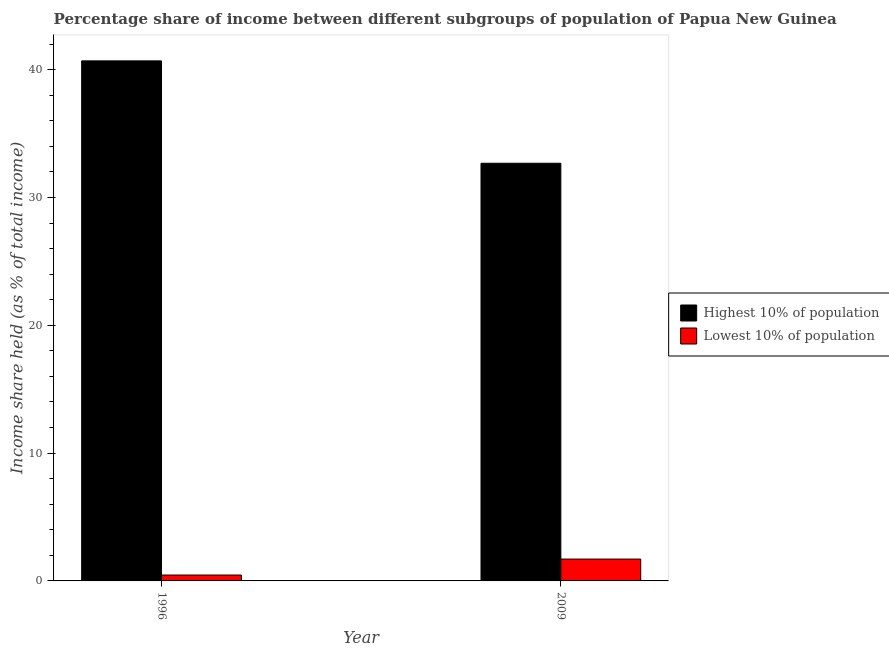How many groups of bars are there?
Your answer should be compact. 2. Are the number of bars per tick equal to the number of legend labels?
Offer a terse response. Yes. How many bars are there on the 1st tick from the left?
Your answer should be compact. 2. What is the income share held by highest 10% of the population in 1996?
Provide a succinct answer. 40.69. Across all years, what is the maximum income share held by lowest 10% of the population?
Provide a succinct answer. 1.71. Across all years, what is the minimum income share held by highest 10% of the population?
Ensure brevity in your answer.  32.68. What is the total income share held by highest 10% of the population in the graph?
Keep it short and to the point. 73.37. What is the difference between the income share held by highest 10% of the population in 1996 and that in 2009?
Keep it short and to the point. 8.01. What is the difference between the income share held by highest 10% of the population in 2009 and the income share held by lowest 10% of the population in 1996?
Your answer should be compact. -8.01. What is the average income share held by lowest 10% of the population per year?
Ensure brevity in your answer.  1.08. In the year 2009, what is the difference between the income share held by lowest 10% of the population and income share held by highest 10% of the population?
Your response must be concise. 0. In how many years, is the income share held by lowest 10% of the population greater than 28 %?
Your response must be concise. 0. What is the ratio of the income share held by highest 10% of the population in 1996 to that in 2009?
Provide a succinct answer. 1.25. Is the income share held by lowest 10% of the population in 1996 less than that in 2009?
Provide a short and direct response. Yes. In how many years, is the income share held by highest 10% of the population greater than the average income share held by highest 10% of the population taken over all years?
Your answer should be compact. 1. What does the 1st bar from the left in 2009 represents?
Provide a succinct answer. Highest 10% of population. What does the 1st bar from the right in 1996 represents?
Give a very brief answer. Lowest 10% of population. How many bars are there?
Your answer should be compact. 4. Are all the bars in the graph horizontal?
Provide a succinct answer. No. How many years are there in the graph?
Offer a terse response. 2. Does the graph contain any zero values?
Give a very brief answer. No. Where does the legend appear in the graph?
Provide a succinct answer. Center right. What is the title of the graph?
Your answer should be compact. Percentage share of income between different subgroups of population of Papua New Guinea. What is the label or title of the Y-axis?
Ensure brevity in your answer.  Income share held (as % of total income). What is the Income share held (as % of total income) in Highest 10% of population in 1996?
Your answer should be compact. 40.69. What is the Income share held (as % of total income) of Lowest 10% of population in 1996?
Provide a succinct answer. 0.46. What is the Income share held (as % of total income) in Highest 10% of population in 2009?
Offer a terse response. 32.68. What is the Income share held (as % of total income) of Lowest 10% of population in 2009?
Provide a succinct answer. 1.71. Across all years, what is the maximum Income share held (as % of total income) of Highest 10% of population?
Make the answer very short. 40.69. Across all years, what is the maximum Income share held (as % of total income) in Lowest 10% of population?
Your answer should be compact. 1.71. Across all years, what is the minimum Income share held (as % of total income) of Highest 10% of population?
Keep it short and to the point. 32.68. Across all years, what is the minimum Income share held (as % of total income) in Lowest 10% of population?
Offer a terse response. 0.46. What is the total Income share held (as % of total income) of Highest 10% of population in the graph?
Keep it short and to the point. 73.37. What is the total Income share held (as % of total income) in Lowest 10% of population in the graph?
Ensure brevity in your answer.  2.17. What is the difference between the Income share held (as % of total income) in Highest 10% of population in 1996 and that in 2009?
Your response must be concise. 8.01. What is the difference between the Income share held (as % of total income) in Lowest 10% of population in 1996 and that in 2009?
Make the answer very short. -1.25. What is the difference between the Income share held (as % of total income) of Highest 10% of population in 1996 and the Income share held (as % of total income) of Lowest 10% of population in 2009?
Your answer should be very brief. 38.98. What is the average Income share held (as % of total income) of Highest 10% of population per year?
Your response must be concise. 36.69. What is the average Income share held (as % of total income) in Lowest 10% of population per year?
Keep it short and to the point. 1.08. In the year 1996, what is the difference between the Income share held (as % of total income) of Highest 10% of population and Income share held (as % of total income) of Lowest 10% of population?
Provide a short and direct response. 40.23. In the year 2009, what is the difference between the Income share held (as % of total income) of Highest 10% of population and Income share held (as % of total income) of Lowest 10% of population?
Your answer should be compact. 30.97. What is the ratio of the Income share held (as % of total income) of Highest 10% of population in 1996 to that in 2009?
Keep it short and to the point. 1.25. What is the ratio of the Income share held (as % of total income) of Lowest 10% of population in 1996 to that in 2009?
Offer a terse response. 0.27. What is the difference between the highest and the second highest Income share held (as % of total income) of Highest 10% of population?
Provide a short and direct response. 8.01. What is the difference between the highest and the lowest Income share held (as % of total income) of Highest 10% of population?
Provide a succinct answer. 8.01. 